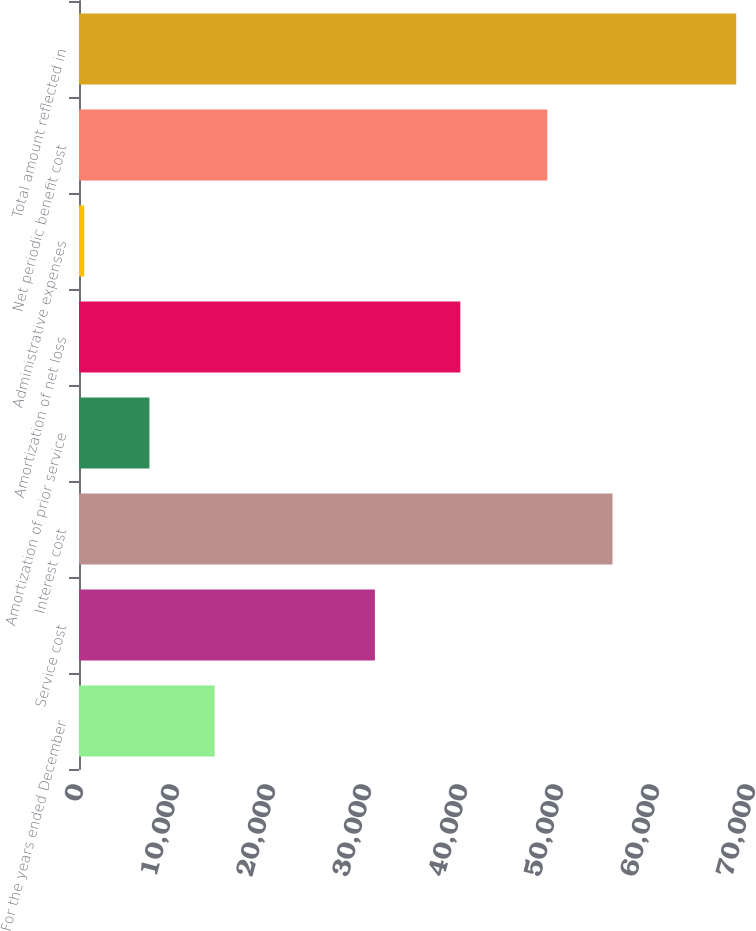Convert chart. <chart><loc_0><loc_0><loc_500><loc_500><bar_chart><fcel>For the years ended December<fcel>Service cost<fcel>Interest cost<fcel>Amortization of prior service<fcel>Amortization of net loss<fcel>Administrative expenses<fcel>Net periodic benefit cost<fcel>Total amount reflected in<nl><fcel>14127.6<fcel>30823<fcel>55573.3<fcel>7336.3<fcel>39723<fcel>545<fcel>48782<fcel>68458<nl></chart> 